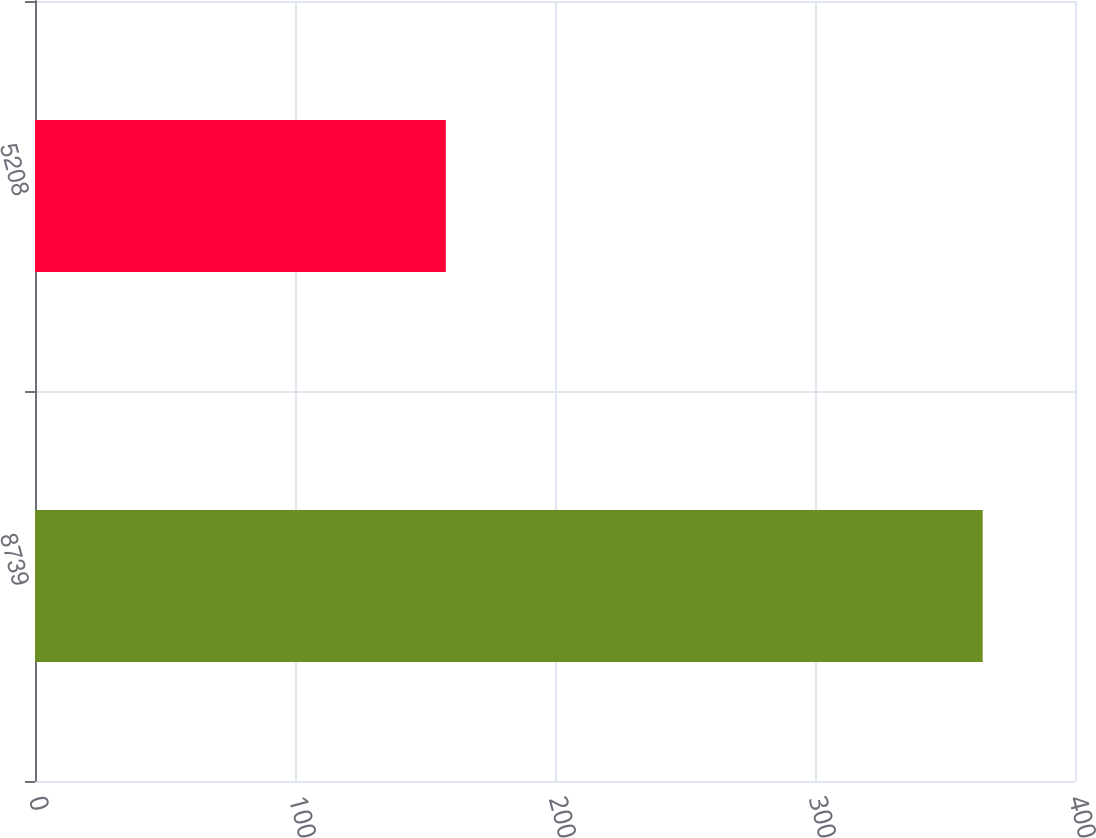<chart> <loc_0><loc_0><loc_500><loc_500><bar_chart><fcel>8739<fcel>5208<nl><fcel>364.5<fcel>158<nl></chart> 